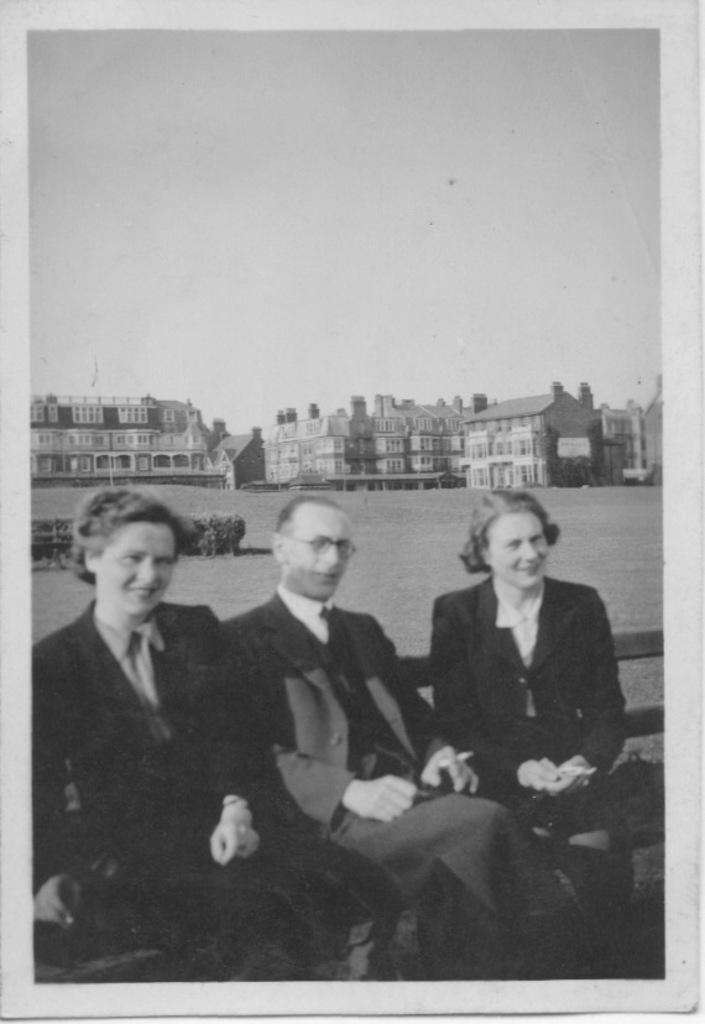Can you describe this image briefly? This is a black and white picture. In the background we can see buildings. Here we can see people sitting and all are smiling. 